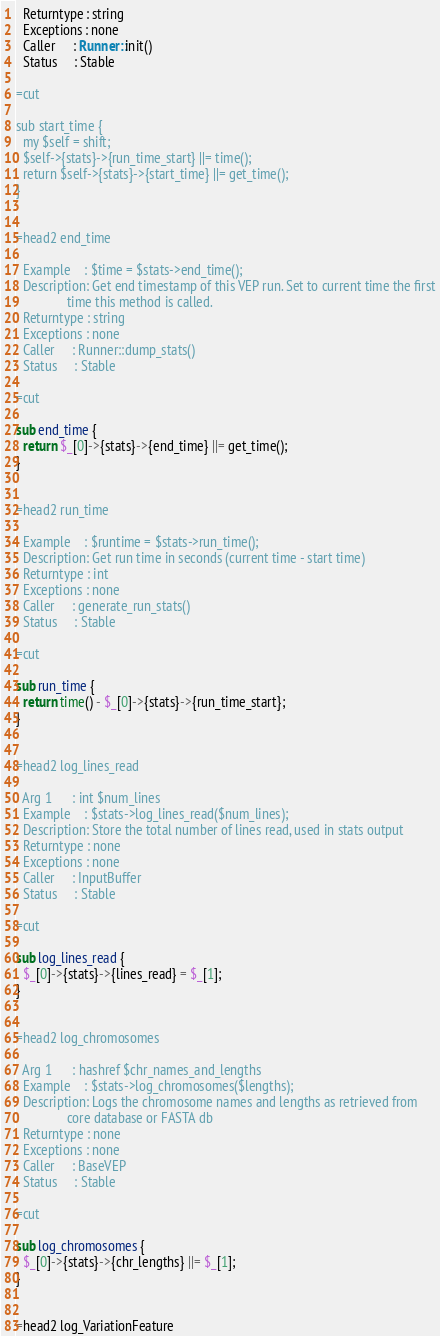Convert code to text. <code><loc_0><loc_0><loc_500><loc_500><_Perl_>  Returntype : string
  Exceptions : none
  Caller     : Runner::init()
  Status     : Stable

=cut

sub start_time {
  my $self = shift;
  $self->{stats}->{run_time_start} ||= time();
  return $self->{stats}->{start_time} ||= get_time();
}


=head2 end_time

  Example    : $time = $stats->end_time();
  Description: Get end timestamp of this VEP run. Set to current time the first
               time this method is called.
  Returntype : string
  Exceptions : none
  Caller     : Runner::dump_stats()
  Status     : Stable

=cut

sub end_time {
  return $_[0]->{stats}->{end_time} ||= get_time();
}


=head2 run_time

  Example    : $runtime = $stats->run_time();
  Description: Get run time in seconds (current time - start time)
  Returntype : int
  Exceptions : none
  Caller     : generate_run_stats()
  Status     : Stable

=cut

sub run_time {
  return time() - $_[0]->{stats}->{run_time_start};
}


=head2 log_lines_read

  Arg 1      : int $num_lines
  Example    : $stats->log_lines_read($num_lines);
  Description: Store the total number of lines read, used in stats output
  Returntype : none
  Exceptions : none
  Caller     : InputBuffer
  Status     : Stable

=cut

sub log_lines_read {
  $_[0]->{stats}->{lines_read} = $_[1];
}


=head2 log_chromosomes

  Arg 1      : hashref $chr_names_and_lengths
  Example    : $stats->log_chromosomes($lengths);
  Description: Logs the chromosome names and lengths as retrieved from
               core database or FASTA db
  Returntype : none
  Exceptions : none
  Caller     : BaseVEP
  Status     : Stable

=cut

sub log_chromosomes {
  $_[0]->{stats}->{chr_lengths} ||= $_[1];
}


=head2 log_VariationFeature
</code> 